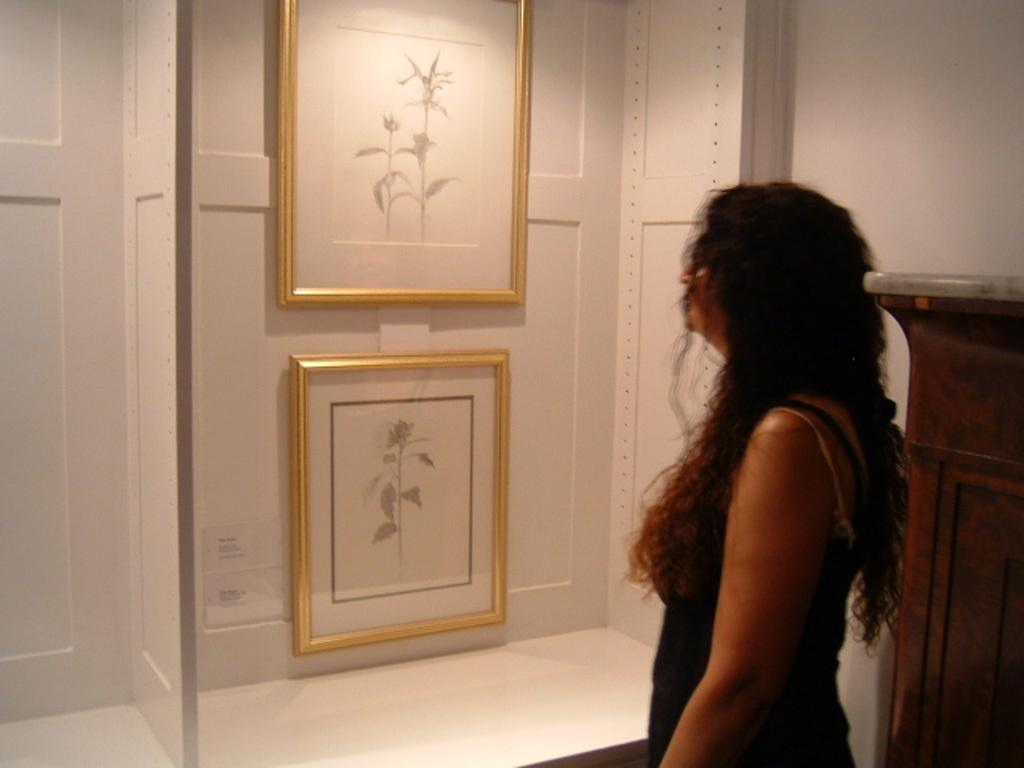What is the woman standing near in the image? The woman is standing near a wooden object on the right side of the image. What can be seen in the background of the image? There is a wall, photo frames, and a poster in the background of the image. What type of chicken can be seen in the image? There is no chicken present in the image. How does the poster affect the acoustics in the room? The provided facts do not mention any information about the poster's effect on the acoustics in the room. --- Facts: 1. There is a person sitting on a chair in the image. 2. The person is holding a book. 3. There is a table in front of the person. 4. There is a lamp on the table. 5. The background of the image is dark. Absurd Topics: parrot, bicycle, ocean Conversation: What is the person in the image doing? The person is sitting on a chair in the image. What is the person holding in the image? The person is holding a book. What object is in front of the person? There is a table in front of the person. What is on the table? There is a lamp on the table. Reasoning: Let's think step by step in order to produce the conversation. We start by identifying the main subject in the image, which is the person sitting on a chair. Then, we expand the conversation to include other elements in the scene, such as the book, table, and lamp. Each question is designed to elicit a specific detail about the image that is known from the provided facts. Absurd Question/Answer: Can you see a parrot sitting on the person's shoulder in the image? No, there is no parrot present in the image. Is the person riding a bicycle in the image? No, the person is sitting on a chair, not riding a bicycle. 